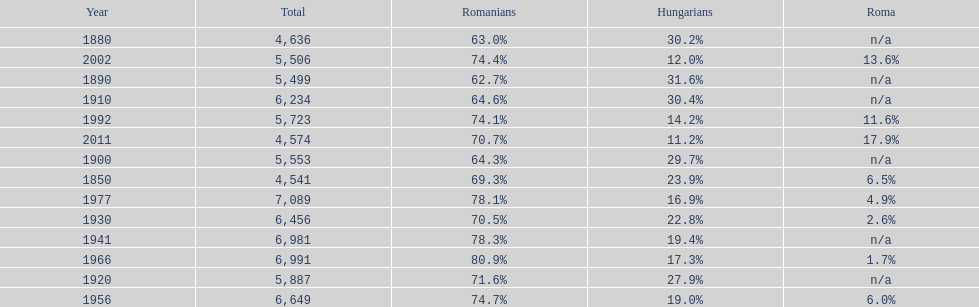In what year was the peak percentage of the romanian population recorded? 1966. 